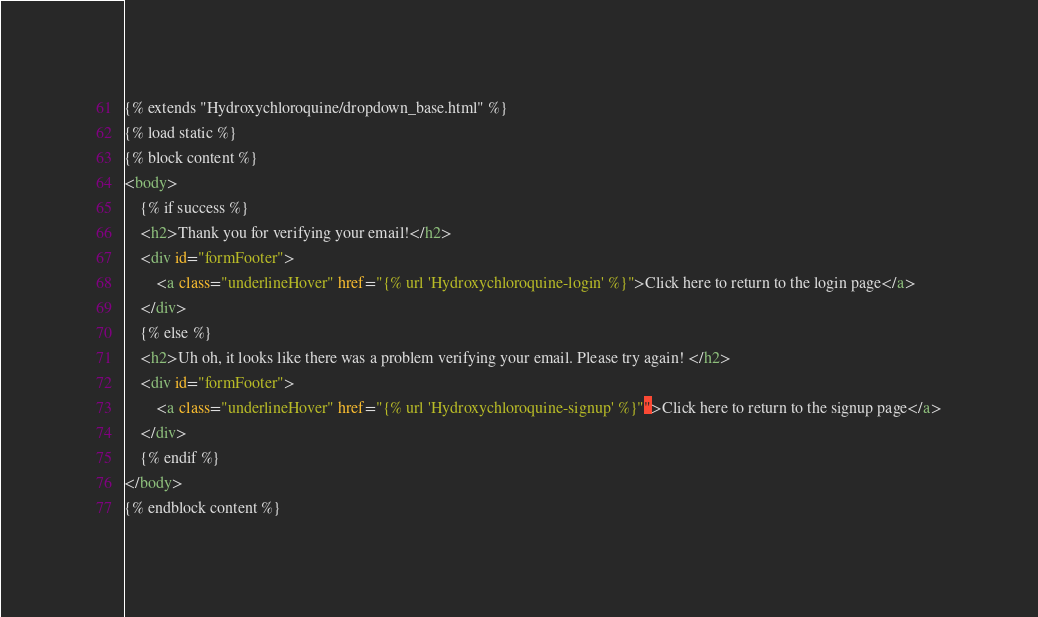Convert code to text. <code><loc_0><loc_0><loc_500><loc_500><_HTML_>
{% extends "Hydroxychloroquine/dropdown_base.html" %}
{% load static %}
{% block content %}
<body>
    {% if success %}
    <h2>Thank you for verifying your email!</h2>
    <div id="formFooter">
        <a class="underlineHover" href="{% url 'Hydroxychloroquine-login' %}">Click here to return to the login page</a>
    </div>
    {% else %}
    <h2>Uh oh, it looks like there was a problem verifying your email. Please try again! </h2>
    <div id="formFooter">
        <a class="underlineHover" href="{% url 'Hydroxychloroquine-signup' %}"">Click here to return to the signup page</a>
    </div>
    {% endif %}
</body>
{% endblock content %}
</code> 